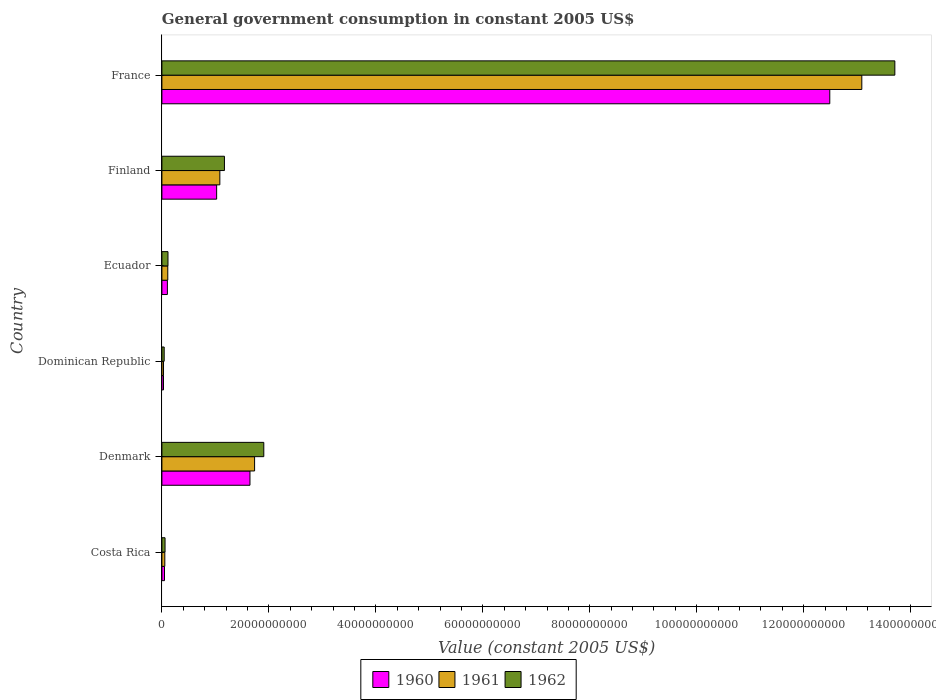How many different coloured bars are there?
Provide a succinct answer. 3. Are the number of bars per tick equal to the number of legend labels?
Keep it short and to the point. Yes. Are the number of bars on each tick of the Y-axis equal?
Provide a short and direct response. Yes. What is the label of the 4th group of bars from the top?
Offer a terse response. Dominican Republic. In how many cases, is the number of bars for a given country not equal to the number of legend labels?
Provide a short and direct response. 0. What is the government conusmption in 1962 in Dominican Republic?
Keep it short and to the point. 4.27e+08. Across all countries, what is the maximum government conusmption in 1961?
Provide a short and direct response. 1.31e+11. Across all countries, what is the minimum government conusmption in 1961?
Ensure brevity in your answer.  3.03e+08. In which country was the government conusmption in 1962 maximum?
Offer a very short reply. France. In which country was the government conusmption in 1962 minimum?
Provide a short and direct response. Dominican Republic. What is the total government conusmption in 1961 in the graph?
Ensure brevity in your answer.  1.61e+11. What is the difference between the government conusmption in 1962 in Finland and that in France?
Offer a terse response. -1.25e+11. What is the difference between the government conusmption in 1962 in Denmark and the government conusmption in 1961 in Ecuador?
Offer a terse response. 1.80e+1. What is the average government conusmption in 1961 per country?
Your response must be concise. 2.68e+1. What is the difference between the government conusmption in 1962 and government conusmption in 1961 in Dominican Republic?
Give a very brief answer. 1.23e+08. What is the ratio of the government conusmption in 1962 in Ecuador to that in Finland?
Your answer should be compact. 0.1. Is the government conusmption in 1962 in Denmark less than that in Dominican Republic?
Make the answer very short. No. What is the difference between the highest and the second highest government conusmption in 1961?
Offer a very short reply. 1.14e+11. What is the difference between the highest and the lowest government conusmption in 1962?
Make the answer very short. 1.37e+11. In how many countries, is the government conusmption in 1960 greater than the average government conusmption in 1960 taken over all countries?
Provide a succinct answer. 1. Is the sum of the government conusmption in 1962 in Costa Rica and Ecuador greater than the maximum government conusmption in 1961 across all countries?
Give a very brief answer. No. What does the 3rd bar from the top in France represents?
Make the answer very short. 1960. What does the 3rd bar from the bottom in Denmark represents?
Ensure brevity in your answer.  1962. Is it the case that in every country, the sum of the government conusmption in 1960 and government conusmption in 1961 is greater than the government conusmption in 1962?
Give a very brief answer. Yes. Are all the bars in the graph horizontal?
Your answer should be compact. Yes. How many countries are there in the graph?
Ensure brevity in your answer.  6. What is the difference between two consecutive major ticks on the X-axis?
Provide a succinct answer. 2.00e+1. Are the values on the major ticks of X-axis written in scientific E-notation?
Offer a terse response. No. Does the graph contain any zero values?
Keep it short and to the point. No. Where does the legend appear in the graph?
Your response must be concise. Bottom center. How many legend labels are there?
Ensure brevity in your answer.  3. What is the title of the graph?
Make the answer very short. General government consumption in constant 2005 US$. Does "2006" appear as one of the legend labels in the graph?
Your answer should be compact. No. What is the label or title of the X-axis?
Your answer should be very brief. Value (constant 2005 US$). What is the label or title of the Y-axis?
Offer a terse response. Country. What is the Value (constant 2005 US$) of 1960 in Costa Rica?
Ensure brevity in your answer.  4.87e+08. What is the Value (constant 2005 US$) in 1961 in Costa Rica?
Your answer should be compact. 5.45e+08. What is the Value (constant 2005 US$) of 1962 in Costa Rica?
Your answer should be compact. 5.88e+08. What is the Value (constant 2005 US$) of 1960 in Denmark?
Keep it short and to the point. 1.65e+1. What is the Value (constant 2005 US$) in 1961 in Denmark?
Your answer should be very brief. 1.73e+1. What is the Value (constant 2005 US$) in 1962 in Denmark?
Offer a terse response. 1.91e+1. What is the Value (constant 2005 US$) in 1960 in Dominican Republic?
Your answer should be compact. 2.99e+08. What is the Value (constant 2005 US$) in 1961 in Dominican Republic?
Keep it short and to the point. 3.03e+08. What is the Value (constant 2005 US$) of 1962 in Dominican Republic?
Your answer should be compact. 4.27e+08. What is the Value (constant 2005 US$) in 1960 in Ecuador?
Provide a succinct answer. 1.03e+09. What is the Value (constant 2005 US$) of 1961 in Ecuador?
Ensure brevity in your answer.  1.10e+09. What is the Value (constant 2005 US$) of 1962 in Ecuador?
Your answer should be compact. 1.14e+09. What is the Value (constant 2005 US$) in 1960 in Finland?
Make the answer very short. 1.02e+1. What is the Value (constant 2005 US$) in 1961 in Finland?
Your answer should be very brief. 1.08e+1. What is the Value (constant 2005 US$) in 1962 in Finland?
Keep it short and to the point. 1.17e+1. What is the Value (constant 2005 US$) of 1960 in France?
Your answer should be very brief. 1.25e+11. What is the Value (constant 2005 US$) of 1961 in France?
Provide a succinct answer. 1.31e+11. What is the Value (constant 2005 US$) in 1962 in France?
Give a very brief answer. 1.37e+11. Across all countries, what is the maximum Value (constant 2005 US$) in 1960?
Ensure brevity in your answer.  1.25e+11. Across all countries, what is the maximum Value (constant 2005 US$) in 1961?
Your answer should be very brief. 1.31e+11. Across all countries, what is the maximum Value (constant 2005 US$) of 1962?
Make the answer very short. 1.37e+11. Across all countries, what is the minimum Value (constant 2005 US$) in 1960?
Keep it short and to the point. 2.99e+08. Across all countries, what is the minimum Value (constant 2005 US$) of 1961?
Provide a succinct answer. 3.03e+08. Across all countries, what is the minimum Value (constant 2005 US$) of 1962?
Offer a terse response. 4.27e+08. What is the total Value (constant 2005 US$) of 1960 in the graph?
Offer a terse response. 1.53e+11. What is the total Value (constant 2005 US$) in 1961 in the graph?
Ensure brevity in your answer.  1.61e+11. What is the total Value (constant 2005 US$) of 1962 in the graph?
Give a very brief answer. 1.70e+11. What is the difference between the Value (constant 2005 US$) in 1960 in Costa Rica and that in Denmark?
Provide a succinct answer. -1.60e+1. What is the difference between the Value (constant 2005 US$) in 1961 in Costa Rica and that in Denmark?
Your answer should be very brief. -1.68e+1. What is the difference between the Value (constant 2005 US$) of 1962 in Costa Rica and that in Denmark?
Your response must be concise. -1.85e+1. What is the difference between the Value (constant 2005 US$) of 1960 in Costa Rica and that in Dominican Republic?
Your response must be concise. 1.88e+08. What is the difference between the Value (constant 2005 US$) in 1961 in Costa Rica and that in Dominican Republic?
Ensure brevity in your answer.  2.41e+08. What is the difference between the Value (constant 2005 US$) of 1962 in Costa Rica and that in Dominican Republic?
Give a very brief answer. 1.61e+08. What is the difference between the Value (constant 2005 US$) of 1960 in Costa Rica and that in Ecuador?
Offer a terse response. -5.39e+08. What is the difference between the Value (constant 2005 US$) in 1961 in Costa Rica and that in Ecuador?
Make the answer very short. -5.55e+08. What is the difference between the Value (constant 2005 US$) in 1962 in Costa Rica and that in Ecuador?
Keep it short and to the point. -5.50e+08. What is the difference between the Value (constant 2005 US$) of 1960 in Costa Rica and that in Finland?
Offer a terse response. -9.75e+09. What is the difference between the Value (constant 2005 US$) in 1961 in Costa Rica and that in Finland?
Your response must be concise. -1.03e+1. What is the difference between the Value (constant 2005 US$) in 1962 in Costa Rica and that in Finland?
Offer a very short reply. -1.11e+1. What is the difference between the Value (constant 2005 US$) in 1960 in Costa Rica and that in France?
Offer a very short reply. -1.24e+11. What is the difference between the Value (constant 2005 US$) of 1961 in Costa Rica and that in France?
Your answer should be compact. -1.30e+11. What is the difference between the Value (constant 2005 US$) in 1962 in Costa Rica and that in France?
Your answer should be very brief. -1.36e+11. What is the difference between the Value (constant 2005 US$) in 1960 in Denmark and that in Dominican Republic?
Make the answer very short. 1.62e+1. What is the difference between the Value (constant 2005 US$) of 1961 in Denmark and that in Dominican Republic?
Keep it short and to the point. 1.70e+1. What is the difference between the Value (constant 2005 US$) of 1962 in Denmark and that in Dominican Republic?
Offer a very short reply. 1.86e+1. What is the difference between the Value (constant 2005 US$) in 1960 in Denmark and that in Ecuador?
Keep it short and to the point. 1.54e+1. What is the difference between the Value (constant 2005 US$) in 1961 in Denmark and that in Ecuador?
Ensure brevity in your answer.  1.62e+1. What is the difference between the Value (constant 2005 US$) in 1962 in Denmark and that in Ecuador?
Your response must be concise. 1.79e+1. What is the difference between the Value (constant 2005 US$) of 1960 in Denmark and that in Finland?
Provide a succinct answer. 6.23e+09. What is the difference between the Value (constant 2005 US$) in 1961 in Denmark and that in Finland?
Give a very brief answer. 6.50e+09. What is the difference between the Value (constant 2005 US$) of 1962 in Denmark and that in Finland?
Offer a terse response. 7.36e+09. What is the difference between the Value (constant 2005 US$) of 1960 in Denmark and that in France?
Ensure brevity in your answer.  -1.08e+11. What is the difference between the Value (constant 2005 US$) of 1961 in Denmark and that in France?
Your answer should be very brief. -1.14e+11. What is the difference between the Value (constant 2005 US$) of 1962 in Denmark and that in France?
Make the answer very short. -1.18e+11. What is the difference between the Value (constant 2005 US$) of 1960 in Dominican Republic and that in Ecuador?
Provide a succinct answer. -7.27e+08. What is the difference between the Value (constant 2005 US$) in 1961 in Dominican Republic and that in Ecuador?
Your answer should be very brief. -7.96e+08. What is the difference between the Value (constant 2005 US$) in 1962 in Dominican Republic and that in Ecuador?
Give a very brief answer. -7.11e+08. What is the difference between the Value (constant 2005 US$) in 1960 in Dominican Republic and that in Finland?
Your answer should be compact. -9.94e+09. What is the difference between the Value (constant 2005 US$) of 1961 in Dominican Republic and that in Finland?
Your response must be concise. -1.05e+1. What is the difference between the Value (constant 2005 US$) in 1962 in Dominican Republic and that in Finland?
Ensure brevity in your answer.  -1.13e+1. What is the difference between the Value (constant 2005 US$) in 1960 in Dominican Republic and that in France?
Offer a terse response. -1.25e+11. What is the difference between the Value (constant 2005 US$) of 1961 in Dominican Republic and that in France?
Your response must be concise. -1.31e+11. What is the difference between the Value (constant 2005 US$) of 1962 in Dominican Republic and that in France?
Make the answer very short. -1.37e+11. What is the difference between the Value (constant 2005 US$) of 1960 in Ecuador and that in Finland?
Provide a succinct answer. -9.21e+09. What is the difference between the Value (constant 2005 US$) in 1961 in Ecuador and that in Finland?
Your answer should be very brief. -9.73e+09. What is the difference between the Value (constant 2005 US$) in 1962 in Ecuador and that in Finland?
Your answer should be compact. -1.06e+1. What is the difference between the Value (constant 2005 US$) of 1960 in Ecuador and that in France?
Your response must be concise. -1.24e+11. What is the difference between the Value (constant 2005 US$) in 1961 in Ecuador and that in France?
Provide a short and direct response. -1.30e+11. What is the difference between the Value (constant 2005 US$) in 1962 in Ecuador and that in France?
Make the answer very short. -1.36e+11. What is the difference between the Value (constant 2005 US$) of 1960 in Finland and that in France?
Ensure brevity in your answer.  -1.15e+11. What is the difference between the Value (constant 2005 US$) of 1961 in Finland and that in France?
Offer a very short reply. -1.20e+11. What is the difference between the Value (constant 2005 US$) of 1962 in Finland and that in France?
Your answer should be compact. -1.25e+11. What is the difference between the Value (constant 2005 US$) in 1960 in Costa Rica and the Value (constant 2005 US$) in 1961 in Denmark?
Your response must be concise. -1.68e+1. What is the difference between the Value (constant 2005 US$) in 1960 in Costa Rica and the Value (constant 2005 US$) in 1962 in Denmark?
Your answer should be very brief. -1.86e+1. What is the difference between the Value (constant 2005 US$) in 1961 in Costa Rica and the Value (constant 2005 US$) in 1962 in Denmark?
Keep it short and to the point. -1.85e+1. What is the difference between the Value (constant 2005 US$) of 1960 in Costa Rica and the Value (constant 2005 US$) of 1961 in Dominican Republic?
Keep it short and to the point. 1.83e+08. What is the difference between the Value (constant 2005 US$) in 1960 in Costa Rica and the Value (constant 2005 US$) in 1962 in Dominican Republic?
Offer a terse response. 6.01e+07. What is the difference between the Value (constant 2005 US$) of 1961 in Costa Rica and the Value (constant 2005 US$) of 1962 in Dominican Republic?
Your answer should be very brief. 1.18e+08. What is the difference between the Value (constant 2005 US$) in 1960 in Costa Rica and the Value (constant 2005 US$) in 1961 in Ecuador?
Give a very brief answer. -6.13e+08. What is the difference between the Value (constant 2005 US$) in 1960 in Costa Rica and the Value (constant 2005 US$) in 1962 in Ecuador?
Offer a very short reply. -6.51e+08. What is the difference between the Value (constant 2005 US$) in 1961 in Costa Rica and the Value (constant 2005 US$) in 1962 in Ecuador?
Offer a very short reply. -5.93e+08. What is the difference between the Value (constant 2005 US$) in 1960 in Costa Rica and the Value (constant 2005 US$) in 1961 in Finland?
Give a very brief answer. -1.03e+1. What is the difference between the Value (constant 2005 US$) in 1960 in Costa Rica and the Value (constant 2005 US$) in 1962 in Finland?
Provide a succinct answer. -1.12e+1. What is the difference between the Value (constant 2005 US$) of 1961 in Costa Rica and the Value (constant 2005 US$) of 1962 in Finland?
Your response must be concise. -1.11e+1. What is the difference between the Value (constant 2005 US$) of 1960 in Costa Rica and the Value (constant 2005 US$) of 1961 in France?
Your response must be concise. -1.30e+11. What is the difference between the Value (constant 2005 US$) in 1960 in Costa Rica and the Value (constant 2005 US$) in 1962 in France?
Your response must be concise. -1.37e+11. What is the difference between the Value (constant 2005 US$) in 1961 in Costa Rica and the Value (constant 2005 US$) in 1962 in France?
Make the answer very short. -1.36e+11. What is the difference between the Value (constant 2005 US$) of 1960 in Denmark and the Value (constant 2005 US$) of 1961 in Dominican Republic?
Offer a terse response. 1.62e+1. What is the difference between the Value (constant 2005 US$) of 1960 in Denmark and the Value (constant 2005 US$) of 1962 in Dominican Republic?
Make the answer very short. 1.60e+1. What is the difference between the Value (constant 2005 US$) in 1961 in Denmark and the Value (constant 2005 US$) in 1962 in Dominican Republic?
Make the answer very short. 1.69e+1. What is the difference between the Value (constant 2005 US$) in 1960 in Denmark and the Value (constant 2005 US$) in 1961 in Ecuador?
Your answer should be compact. 1.54e+1. What is the difference between the Value (constant 2005 US$) in 1960 in Denmark and the Value (constant 2005 US$) in 1962 in Ecuador?
Provide a succinct answer. 1.53e+1. What is the difference between the Value (constant 2005 US$) in 1961 in Denmark and the Value (constant 2005 US$) in 1962 in Ecuador?
Ensure brevity in your answer.  1.62e+1. What is the difference between the Value (constant 2005 US$) in 1960 in Denmark and the Value (constant 2005 US$) in 1961 in Finland?
Provide a succinct answer. 5.63e+09. What is the difference between the Value (constant 2005 US$) in 1960 in Denmark and the Value (constant 2005 US$) in 1962 in Finland?
Offer a very short reply. 4.77e+09. What is the difference between the Value (constant 2005 US$) of 1961 in Denmark and the Value (constant 2005 US$) of 1962 in Finland?
Offer a very short reply. 5.64e+09. What is the difference between the Value (constant 2005 US$) in 1960 in Denmark and the Value (constant 2005 US$) in 1961 in France?
Your answer should be very brief. -1.14e+11. What is the difference between the Value (constant 2005 US$) in 1960 in Denmark and the Value (constant 2005 US$) in 1962 in France?
Provide a succinct answer. -1.21e+11. What is the difference between the Value (constant 2005 US$) in 1961 in Denmark and the Value (constant 2005 US$) in 1962 in France?
Provide a succinct answer. -1.20e+11. What is the difference between the Value (constant 2005 US$) in 1960 in Dominican Republic and the Value (constant 2005 US$) in 1961 in Ecuador?
Offer a very short reply. -8.01e+08. What is the difference between the Value (constant 2005 US$) of 1960 in Dominican Republic and the Value (constant 2005 US$) of 1962 in Ecuador?
Your answer should be very brief. -8.39e+08. What is the difference between the Value (constant 2005 US$) in 1961 in Dominican Republic and the Value (constant 2005 US$) in 1962 in Ecuador?
Your answer should be very brief. -8.35e+08. What is the difference between the Value (constant 2005 US$) of 1960 in Dominican Republic and the Value (constant 2005 US$) of 1961 in Finland?
Keep it short and to the point. -1.05e+1. What is the difference between the Value (constant 2005 US$) of 1960 in Dominican Republic and the Value (constant 2005 US$) of 1962 in Finland?
Provide a short and direct response. -1.14e+1. What is the difference between the Value (constant 2005 US$) in 1961 in Dominican Republic and the Value (constant 2005 US$) in 1962 in Finland?
Offer a terse response. -1.14e+1. What is the difference between the Value (constant 2005 US$) in 1960 in Dominican Republic and the Value (constant 2005 US$) in 1961 in France?
Your response must be concise. -1.31e+11. What is the difference between the Value (constant 2005 US$) of 1960 in Dominican Republic and the Value (constant 2005 US$) of 1962 in France?
Offer a very short reply. -1.37e+11. What is the difference between the Value (constant 2005 US$) in 1961 in Dominican Republic and the Value (constant 2005 US$) in 1962 in France?
Your answer should be compact. -1.37e+11. What is the difference between the Value (constant 2005 US$) in 1960 in Ecuador and the Value (constant 2005 US$) in 1961 in Finland?
Keep it short and to the point. -9.81e+09. What is the difference between the Value (constant 2005 US$) of 1960 in Ecuador and the Value (constant 2005 US$) of 1962 in Finland?
Your answer should be very brief. -1.07e+1. What is the difference between the Value (constant 2005 US$) of 1961 in Ecuador and the Value (constant 2005 US$) of 1962 in Finland?
Your answer should be very brief. -1.06e+1. What is the difference between the Value (constant 2005 US$) of 1960 in Ecuador and the Value (constant 2005 US$) of 1961 in France?
Make the answer very short. -1.30e+11. What is the difference between the Value (constant 2005 US$) in 1960 in Ecuador and the Value (constant 2005 US$) in 1962 in France?
Your answer should be compact. -1.36e+11. What is the difference between the Value (constant 2005 US$) of 1961 in Ecuador and the Value (constant 2005 US$) of 1962 in France?
Provide a short and direct response. -1.36e+11. What is the difference between the Value (constant 2005 US$) in 1960 in Finland and the Value (constant 2005 US$) in 1961 in France?
Provide a succinct answer. -1.21e+11. What is the difference between the Value (constant 2005 US$) of 1960 in Finland and the Value (constant 2005 US$) of 1962 in France?
Offer a very short reply. -1.27e+11. What is the difference between the Value (constant 2005 US$) of 1961 in Finland and the Value (constant 2005 US$) of 1962 in France?
Offer a very short reply. -1.26e+11. What is the average Value (constant 2005 US$) in 1960 per country?
Provide a short and direct response. 2.56e+1. What is the average Value (constant 2005 US$) in 1961 per country?
Provide a short and direct response. 2.68e+1. What is the average Value (constant 2005 US$) of 1962 per country?
Your answer should be very brief. 2.83e+1. What is the difference between the Value (constant 2005 US$) in 1960 and Value (constant 2005 US$) in 1961 in Costa Rica?
Keep it short and to the point. -5.79e+07. What is the difference between the Value (constant 2005 US$) in 1960 and Value (constant 2005 US$) in 1962 in Costa Rica?
Make the answer very short. -1.01e+08. What is the difference between the Value (constant 2005 US$) in 1961 and Value (constant 2005 US$) in 1962 in Costa Rica?
Provide a short and direct response. -4.32e+07. What is the difference between the Value (constant 2005 US$) in 1960 and Value (constant 2005 US$) in 1961 in Denmark?
Your answer should be very brief. -8.65e+08. What is the difference between the Value (constant 2005 US$) in 1960 and Value (constant 2005 US$) in 1962 in Denmark?
Provide a succinct answer. -2.59e+09. What is the difference between the Value (constant 2005 US$) in 1961 and Value (constant 2005 US$) in 1962 in Denmark?
Offer a terse response. -1.72e+09. What is the difference between the Value (constant 2005 US$) in 1960 and Value (constant 2005 US$) in 1961 in Dominican Republic?
Keep it short and to the point. -4.75e+06. What is the difference between the Value (constant 2005 US$) of 1960 and Value (constant 2005 US$) of 1962 in Dominican Republic?
Provide a succinct answer. -1.28e+08. What is the difference between the Value (constant 2005 US$) in 1961 and Value (constant 2005 US$) in 1962 in Dominican Republic?
Keep it short and to the point. -1.23e+08. What is the difference between the Value (constant 2005 US$) in 1960 and Value (constant 2005 US$) in 1961 in Ecuador?
Your response must be concise. -7.35e+07. What is the difference between the Value (constant 2005 US$) of 1960 and Value (constant 2005 US$) of 1962 in Ecuador?
Your answer should be very brief. -1.12e+08. What is the difference between the Value (constant 2005 US$) in 1961 and Value (constant 2005 US$) in 1962 in Ecuador?
Give a very brief answer. -3.85e+07. What is the difference between the Value (constant 2005 US$) of 1960 and Value (constant 2005 US$) of 1961 in Finland?
Provide a short and direct response. -5.98e+08. What is the difference between the Value (constant 2005 US$) in 1960 and Value (constant 2005 US$) in 1962 in Finland?
Ensure brevity in your answer.  -1.46e+09. What is the difference between the Value (constant 2005 US$) of 1961 and Value (constant 2005 US$) of 1962 in Finland?
Provide a succinct answer. -8.59e+08. What is the difference between the Value (constant 2005 US$) in 1960 and Value (constant 2005 US$) in 1961 in France?
Give a very brief answer. -5.99e+09. What is the difference between the Value (constant 2005 US$) in 1960 and Value (constant 2005 US$) in 1962 in France?
Provide a short and direct response. -1.22e+1. What is the difference between the Value (constant 2005 US$) of 1961 and Value (constant 2005 US$) of 1962 in France?
Ensure brevity in your answer.  -6.18e+09. What is the ratio of the Value (constant 2005 US$) in 1960 in Costa Rica to that in Denmark?
Your answer should be very brief. 0.03. What is the ratio of the Value (constant 2005 US$) of 1961 in Costa Rica to that in Denmark?
Provide a succinct answer. 0.03. What is the ratio of the Value (constant 2005 US$) of 1962 in Costa Rica to that in Denmark?
Make the answer very short. 0.03. What is the ratio of the Value (constant 2005 US$) of 1960 in Costa Rica to that in Dominican Republic?
Give a very brief answer. 1.63. What is the ratio of the Value (constant 2005 US$) in 1961 in Costa Rica to that in Dominican Republic?
Provide a succinct answer. 1.8. What is the ratio of the Value (constant 2005 US$) in 1962 in Costa Rica to that in Dominican Republic?
Provide a short and direct response. 1.38. What is the ratio of the Value (constant 2005 US$) of 1960 in Costa Rica to that in Ecuador?
Offer a terse response. 0.47. What is the ratio of the Value (constant 2005 US$) of 1961 in Costa Rica to that in Ecuador?
Your answer should be compact. 0.5. What is the ratio of the Value (constant 2005 US$) in 1962 in Costa Rica to that in Ecuador?
Keep it short and to the point. 0.52. What is the ratio of the Value (constant 2005 US$) in 1960 in Costa Rica to that in Finland?
Your answer should be compact. 0.05. What is the ratio of the Value (constant 2005 US$) of 1961 in Costa Rica to that in Finland?
Provide a succinct answer. 0.05. What is the ratio of the Value (constant 2005 US$) of 1962 in Costa Rica to that in Finland?
Offer a very short reply. 0.05. What is the ratio of the Value (constant 2005 US$) in 1960 in Costa Rica to that in France?
Make the answer very short. 0. What is the ratio of the Value (constant 2005 US$) of 1961 in Costa Rica to that in France?
Your answer should be compact. 0. What is the ratio of the Value (constant 2005 US$) in 1962 in Costa Rica to that in France?
Make the answer very short. 0. What is the ratio of the Value (constant 2005 US$) of 1960 in Denmark to that in Dominican Republic?
Your response must be concise. 55.14. What is the ratio of the Value (constant 2005 US$) of 1961 in Denmark to that in Dominican Republic?
Make the answer very short. 57.13. What is the ratio of the Value (constant 2005 US$) in 1962 in Denmark to that in Dominican Republic?
Your response must be concise. 44.66. What is the ratio of the Value (constant 2005 US$) in 1960 in Denmark to that in Ecuador?
Provide a succinct answer. 16.05. What is the ratio of the Value (constant 2005 US$) of 1961 in Denmark to that in Ecuador?
Ensure brevity in your answer.  15.76. What is the ratio of the Value (constant 2005 US$) in 1962 in Denmark to that in Ecuador?
Your answer should be very brief. 16.74. What is the ratio of the Value (constant 2005 US$) of 1960 in Denmark to that in Finland?
Your answer should be very brief. 1.61. What is the ratio of the Value (constant 2005 US$) in 1961 in Denmark to that in Finland?
Offer a very short reply. 1.6. What is the ratio of the Value (constant 2005 US$) in 1962 in Denmark to that in Finland?
Provide a short and direct response. 1.63. What is the ratio of the Value (constant 2005 US$) of 1960 in Denmark to that in France?
Ensure brevity in your answer.  0.13. What is the ratio of the Value (constant 2005 US$) in 1961 in Denmark to that in France?
Make the answer very short. 0.13. What is the ratio of the Value (constant 2005 US$) in 1962 in Denmark to that in France?
Give a very brief answer. 0.14. What is the ratio of the Value (constant 2005 US$) in 1960 in Dominican Republic to that in Ecuador?
Make the answer very short. 0.29. What is the ratio of the Value (constant 2005 US$) of 1961 in Dominican Republic to that in Ecuador?
Keep it short and to the point. 0.28. What is the ratio of the Value (constant 2005 US$) of 1962 in Dominican Republic to that in Ecuador?
Your response must be concise. 0.37. What is the ratio of the Value (constant 2005 US$) of 1960 in Dominican Republic to that in Finland?
Make the answer very short. 0.03. What is the ratio of the Value (constant 2005 US$) of 1961 in Dominican Republic to that in Finland?
Make the answer very short. 0.03. What is the ratio of the Value (constant 2005 US$) of 1962 in Dominican Republic to that in Finland?
Your response must be concise. 0.04. What is the ratio of the Value (constant 2005 US$) in 1960 in Dominican Republic to that in France?
Offer a terse response. 0. What is the ratio of the Value (constant 2005 US$) in 1961 in Dominican Republic to that in France?
Your answer should be very brief. 0. What is the ratio of the Value (constant 2005 US$) in 1962 in Dominican Republic to that in France?
Keep it short and to the point. 0. What is the ratio of the Value (constant 2005 US$) of 1960 in Ecuador to that in Finland?
Provide a short and direct response. 0.1. What is the ratio of the Value (constant 2005 US$) in 1961 in Ecuador to that in Finland?
Give a very brief answer. 0.1. What is the ratio of the Value (constant 2005 US$) in 1962 in Ecuador to that in Finland?
Ensure brevity in your answer.  0.1. What is the ratio of the Value (constant 2005 US$) of 1960 in Ecuador to that in France?
Give a very brief answer. 0.01. What is the ratio of the Value (constant 2005 US$) of 1961 in Ecuador to that in France?
Give a very brief answer. 0.01. What is the ratio of the Value (constant 2005 US$) in 1962 in Ecuador to that in France?
Your answer should be very brief. 0.01. What is the ratio of the Value (constant 2005 US$) in 1960 in Finland to that in France?
Ensure brevity in your answer.  0.08. What is the ratio of the Value (constant 2005 US$) in 1961 in Finland to that in France?
Keep it short and to the point. 0.08. What is the ratio of the Value (constant 2005 US$) of 1962 in Finland to that in France?
Your answer should be compact. 0.09. What is the difference between the highest and the second highest Value (constant 2005 US$) of 1960?
Your response must be concise. 1.08e+11. What is the difference between the highest and the second highest Value (constant 2005 US$) of 1961?
Provide a succinct answer. 1.14e+11. What is the difference between the highest and the second highest Value (constant 2005 US$) of 1962?
Make the answer very short. 1.18e+11. What is the difference between the highest and the lowest Value (constant 2005 US$) in 1960?
Your answer should be compact. 1.25e+11. What is the difference between the highest and the lowest Value (constant 2005 US$) in 1961?
Your response must be concise. 1.31e+11. What is the difference between the highest and the lowest Value (constant 2005 US$) in 1962?
Keep it short and to the point. 1.37e+11. 